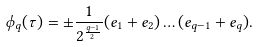Convert formula to latex. <formula><loc_0><loc_0><loc_500><loc_500>\phi _ { q } ( \tau ) = \pm \frac { 1 } { 2 ^ { \frac { q - 1 } { 2 } } } ( e _ { 1 } + e _ { 2 } ) \dots ( e _ { q - 1 } + e _ { q } ) .</formula> 